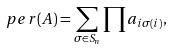<formula> <loc_0><loc_0><loc_500><loc_500>p e r ( A ) = \sum _ { \sigma \in S _ { n } } \prod a _ { i \sigma ( i ) } ,</formula> 